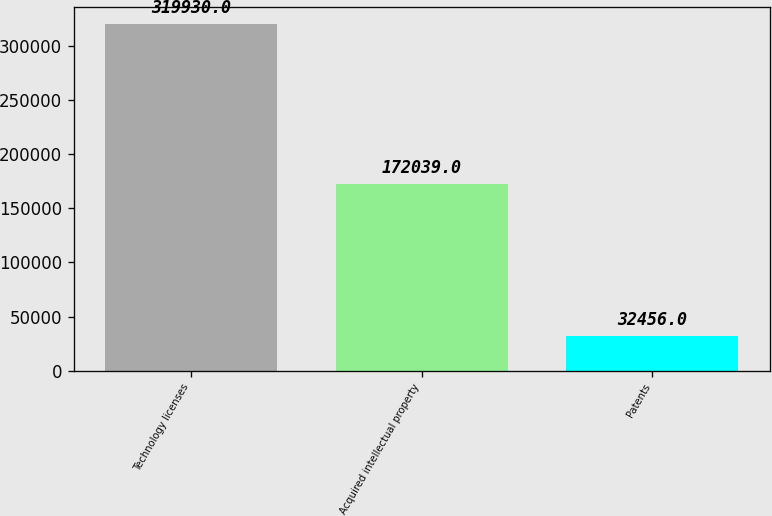Convert chart. <chart><loc_0><loc_0><loc_500><loc_500><bar_chart><fcel>Technology licenses<fcel>Acquired intellectual property<fcel>Patents<nl><fcel>319930<fcel>172039<fcel>32456<nl></chart> 